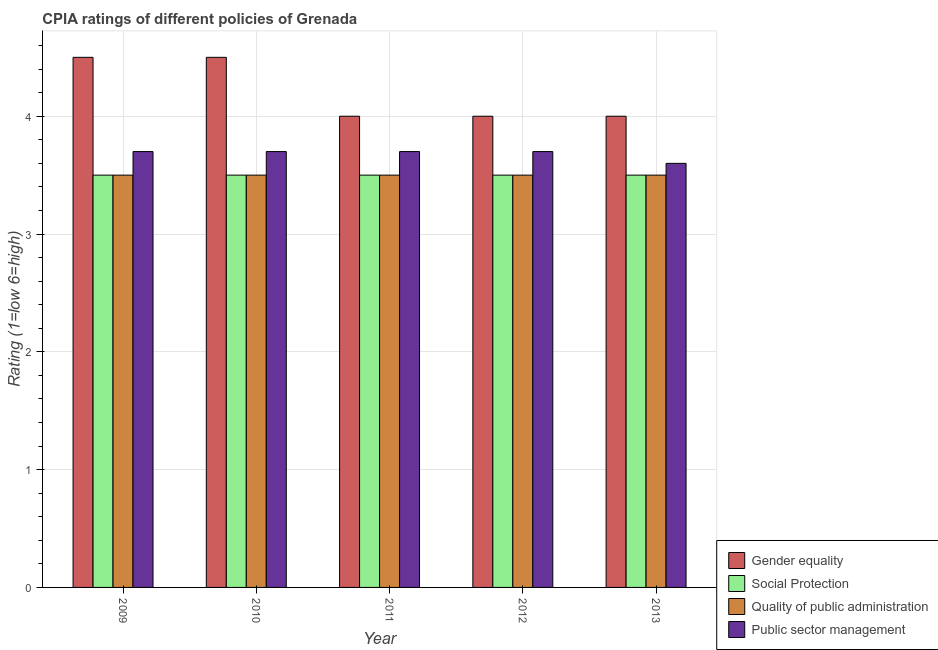How many different coloured bars are there?
Provide a succinct answer. 4. Are the number of bars per tick equal to the number of legend labels?
Your answer should be very brief. Yes. Are the number of bars on each tick of the X-axis equal?
Offer a terse response. Yes. How many bars are there on the 3rd tick from the right?
Your response must be concise. 4. In how many cases, is the number of bars for a given year not equal to the number of legend labels?
Keep it short and to the point. 0. What is the cpia rating of quality of public administration in 2009?
Offer a very short reply. 3.5. Across all years, what is the maximum cpia rating of quality of public administration?
Provide a succinct answer. 3.5. In which year was the cpia rating of quality of public administration maximum?
Make the answer very short. 2009. In which year was the cpia rating of gender equality minimum?
Ensure brevity in your answer.  2011. What is the total cpia rating of public sector management in the graph?
Offer a terse response. 18.4. What is the difference between the cpia rating of social protection in 2009 and that in 2011?
Provide a succinct answer. 0. What is the difference between the cpia rating of gender equality in 2013 and the cpia rating of public sector management in 2009?
Provide a succinct answer. -0.5. In the year 2013, what is the difference between the cpia rating of social protection and cpia rating of public sector management?
Provide a succinct answer. 0. What is the ratio of the cpia rating of public sector management in 2011 to that in 2013?
Make the answer very short. 1.03. Is the cpia rating of social protection in 2011 less than that in 2013?
Your answer should be compact. No. In how many years, is the cpia rating of gender equality greater than the average cpia rating of gender equality taken over all years?
Keep it short and to the point. 2. Is the sum of the cpia rating of social protection in 2012 and 2013 greater than the maximum cpia rating of gender equality across all years?
Give a very brief answer. Yes. What does the 3rd bar from the left in 2009 represents?
Ensure brevity in your answer.  Quality of public administration. What does the 1st bar from the right in 2011 represents?
Your answer should be compact. Public sector management. How many bars are there?
Offer a very short reply. 20. Are all the bars in the graph horizontal?
Your answer should be compact. No. What is the difference between two consecutive major ticks on the Y-axis?
Give a very brief answer. 1. Are the values on the major ticks of Y-axis written in scientific E-notation?
Your answer should be very brief. No. Does the graph contain any zero values?
Your answer should be very brief. No. Does the graph contain grids?
Your answer should be very brief. Yes. How many legend labels are there?
Provide a short and direct response. 4. What is the title of the graph?
Keep it short and to the point. CPIA ratings of different policies of Grenada. What is the Rating (1=low 6=high) of Gender equality in 2009?
Your answer should be very brief. 4.5. What is the Rating (1=low 6=high) in Social Protection in 2009?
Offer a terse response. 3.5. What is the Rating (1=low 6=high) in Gender equality in 2010?
Your answer should be compact. 4.5. What is the Rating (1=low 6=high) of Gender equality in 2011?
Keep it short and to the point. 4. What is the Rating (1=low 6=high) in Quality of public administration in 2011?
Your answer should be compact. 3.5. What is the Rating (1=low 6=high) in Quality of public administration in 2012?
Give a very brief answer. 3.5. What is the Rating (1=low 6=high) in Gender equality in 2013?
Offer a very short reply. 4. What is the Rating (1=low 6=high) in Social Protection in 2013?
Keep it short and to the point. 3.5. What is the Rating (1=low 6=high) of Public sector management in 2013?
Provide a short and direct response. 3.6. Across all years, what is the maximum Rating (1=low 6=high) in Public sector management?
Provide a short and direct response. 3.7. Across all years, what is the minimum Rating (1=low 6=high) in Gender equality?
Keep it short and to the point. 4. What is the total Rating (1=low 6=high) of Quality of public administration in the graph?
Your answer should be compact. 17.5. What is the difference between the Rating (1=low 6=high) of Gender equality in 2009 and that in 2010?
Provide a short and direct response. 0. What is the difference between the Rating (1=low 6=high) of Social Protection in 2009 and that in 2011?
Keep it short and to the point. 0. What is the difference between the Rating (1=low 6=high) in Quality of public administration in 2009 and that in 2011?
Provide a short and direct response. 0. What is the difference between the Rating (1=low 6=high) in Public sector management in 2009 and that in 2011?
Your answer should be compact. 0. What is the difference between the Rating (1=low 6=high) in Gender equality in 2009 and that in 2012?
Offer a very short reply. 0.5. What is the difference between the Rating (1=low 6=high) of Social Protection in 2009 and that in 2012?
Offer a terse response. 0. What is the difference between the Rating (1=low 6=high) in Quality of public administration in 2009 and that in 2013?
Provide a short and direct response. 0. What is the difference between the Rating (1=low 6=high) in Public sector management in 2009 and that in 2013?
Provide a succinct answer. 0.1. What is the difference between the Rating (1=low 6=high) in Social Protection in 2010 and that in 2011?
Give a very brief answer. 0. What is the difference between the Rating (1=low 6=high) in Quality of public administration in 2010 and that in 2011?
Provide a short and direct response. 0. What is the difference between the Rating (1=low 6=high) in Gender equality in 2010 and that in 2012?
Your answer should be very brief. 0.5. What is the difference between the Rating (1=low 6=high) of Social Protection in 2010 and that in 2012?
Provide a short and direct response. 0. What is the difference between the Rating (1=low 6=high) of Quality of public administration in 2010 and that in 2012?
Your response must be concise. 0. What is the difference between the Rating (1=low 6=high) of Public sector management in 2010 and that in 2012?
Keep it short and to the point. 0. What is the difference between the Rating (1=low 6=high) in Social Protection in 2010 and that in 2013?
Your response must be concise. 0. What is the difference between the Rating (1=low 6=high) in Social Protection in 2011 and that in 2012?
Keep it short and to the point. 0. What is the difference between the Rating (1=low 6=high) in Quality of public administration in 2011 and that in 2012?
Offer a terse response. 0. What is the difference between the Rating (1=low 6=high) in Gender equality in 2011 and that in 2013?
Provide a succinct answer. 0. What is the difference between the Rating (1=low 6=high) of Quality of public administration in 2011 and that in 2013?
Your answer should be compact. 0. What is the difference between the Rating (1=low 6=high) of Public sector management in 2011 and that in 2013?
Give a very brief answer. 0.1. What is the difference between the Rating (1=low 6=high) in Gender equality in 2012 and that in 2013?
Make the answer very short. 0. What is the difference between the Rating (1=low 6=high) in Public sector management in 2012 and that in 2013?
Give a very brief answer. 0.1. What is the difference between the Rating (1=low 6=high) of Gender equality in 2009 and the Rating (1=low 6=high) of Social Protection in 2010?
Provide a succinct answer. 1. What is the difference between the Rating (1=low 6=high) in Gender equality in 2009 and the Rating (1=low 6=high) in Public sector management in 2010?
Your answer should be compact. 0.8. What is the difference between the Rating (1=low 6=high) of Quality of public administration in 2009 and the Rating (1=low 6=high) of Public sector management in 2010?
Keep it short and to the point. -0.2. What is the difference between the Rating (1=low 6=high) of Gender equality in 2009 and the Rating (1=low 6=high) of Public sector management in 2011?
Your answer should be compact. 0.8. What is the difference between the Rating (1=low 6=high) of Social Protection in 2009 and the Rating (1=low 6=high) of Quality of public administration in 2011?
Your response must be concise. 0. What is the difference between the Rating (1=low 6=high) of Social Protection in 2009 and the Rating (1=low 6=high) of Public sector management in 2011?
Provide a succinct answer. -0.2. What is the difference between the Rating (1=low 6=high) in Gender equality in 2009 and the Rating (1=low 6=high) in Quality of public administration in 2012?
Give a very brief answer. 1. What is the difference between the Rating (1=low 6=high) in Social Protection in 2009 and the Rating (1=low 6=high) in Public sector management in 2012?
Offer a very short reply. -0.2. What is the difference between the Rating (1=low 6=high) in Quality of public administration in 2009 and the Rating (1=low 6=high) in Public sector management in 2012?
Your answer should be compact. -0.2. What is the difference between the Rating (1=low 6=high) in Gender equality in 2009 and the Rating (1=low 6=high) in Quality of public administration in 2013?
Your answer should be compact. 1. What is the difference between the Rating (1=low 6=high) of Gender equality in 2009 and the Rating (1=low 6=high) of Public sector management in 2013?
Offer a terse response. 0.9. What is the difference between the Rating (1=low 6=high) in Social Protection in 2009 and the Rating (1=low 6=high) in Public sector management in 2013?
Offer a terse response. -0.1. What is the difference between the Rating (1=low 6=high) in Quality of public administration in 2009 and the Rating (1=low 6=high) in Public sector management in 2013?
Your answer should be very brief. -0.1. What is the difference between the Rating (1=low 6=high) in Gender equality in 2010 and the Rating (1=low 6=high) in Social Protection in 2011?
Your answer should be compact. 1. What is the difference between the Rating (1=low 6=high) in Gender equality in 2010 and the Rating (1=low 6=high) in Public sector management in 2011?
Offer a very short reply. 0.8. What is the difference between the Rating (1=low 6=high) of Social Protection in 2010 and the Rating (1=low 6=high) of Quality of public administration in 2011?
Keep it short and to the point. 0. What is the difference between the Rating (1=low 6=high) of Social Protection in 2010 and the Rating (1=low 6=high) of Public sector management in 2011?
Give a very brief answer. -0.2. What is the difference between the Rating (1=low 6=high) in Gender equality in 2010 and the Rating (1=low 6=high) in Social Protection in 2012?
Provide a succinct answer. 1. What is the difference between the Rating (1=low 6=high) in Gender equality in 2010 and the Rating (1=low 6=high) in Quality of public administration in 2012?
Your answer should be very brief. 1. What is the difference between the Rating (1=low 6=high) of Gender equality in 2010 and the Rating (1=low 6=high) of Public sector management in 2012?
Ensure brevity in your answer.  0.8. What is the difference between the Rating (1=low 6=high) in Gender equality in 2010 and the Rating (1=low 6=high) in Quality of public administration in 2013?
Ensure brevity in your answer.  1. What is the difference between the Rating (1=low 6=high) in Social Protection in 2010 and the Rating (1=low 6=high) in Quality of public administration in 2013?
Make the answer very short. 0. What is the difference between the Rating (1=low 6=high) of Gender equality in 2011 and the Rating (1=low 6=high) of Social Protection in 2012?
Your answer should be very brief. 0.5. What is the difference between the Rating (1=low 6=high) in Gender equality in 2011 and the Rating (1=low 6=high) in Quality of public administration in 2012?
Offer a terse response. 0.5. What is the difference between the Rating (1=low 6=high) in Gender equality in 2011 and the Rating (1=low 6=high) in Public sector management in 2012?
Offer a very short reply. 0.3. What is the difference between the Rating (1=low 6=high) of Social Protection in 2011 and the Rating (1=low 6=high) of Public sector management in 2012?
Ensure brevity in your answer.  -0.2. What is the difference between the Rating (1=low 6=high) of Quality of public administration in 2011 and the Rating (1=low 6=high) of Public sector management in 2012?
Your answer should be very brief. -0.2. What is the difference between the Rating (1=low 6=high) in Gender equality in 2011 and the Rating (1=low 6=high) in Public sector management in 2013?
Make the answer very short. 0.4. What is the difference between the Rating (1=low 6=high) in Social Protection in 2011 and the Rating (1=low 6=high) in Quality of public administration in 2013?
Make the answer very short. 0. What is the difference between the Rating (1=low 6=high) of Social Protection in 2011 and the Rating (1=low 6=high) of Public sector management in 2013?
Ensure brevity in your answer.  -0.1. What is the difference between the Rating (1=low 6=high) in Quality of public administration in 2011 and the Rating (1=low 6=high) in Public sector management in 2013?
Ensure brevity in your answer.  -0.1. What is the difference between the Rating (1=low 6=high) of Gender equality in 2012 and the Rating (1=low 6=high) of Quality of public administration in 2013?
Give a very brief answer. 0.5. What is the difference between the Rating (1=low 6=high) in Quality of public administration in 2012 and the Rating (1=low 6=high) in Public sector management in 2013?
Offer a terse response. -0.1. What is the average Rating (1=low 6=high) of Gender equality per year?
Provide a succinct answer. 4.2. What is the average Rating (1=low 6=high) in Quality of public administration per year?
Your answer should be compact. 3.5. What is the average Rating (1=low 6=high) of Public sector management per year?
Provide a succinct answer. 3.68. In the year 2009, what is the difference between the Rating (1=low 6=high) in Gender equality and Rating (1=low 6=high) in Quality of public administration?
Provide a short and direct response. 1. In the year 2009, what is the difference between the Rating (1=low 6=high) in Social Protection and Rating (1=low 6=high) in Public sector management?
Offer a very short reply. -0.2. In the year 2009, what is the difference between the Rating (1=low 6=high) in Quality of public administration and Rating (1=low 6=high) in Public sector management?
Make the answer very short. -0.2. In the year 2010, what is the difference between the Rating (1=low 6=high) of Gender equality and Rating (1=low 6=high) of Social Protection?
Give a very brief answer. 1. In the year 2010, what is the difference between the Rating (1=low 6=high) of Gender equality and Rating (1=low 6=high) of Quality of public administration?
Your answer should be compact. 1. In the year 2010, what is the difference between the Rating (1=low 6=high) of Gender equality and Rating (1=low 6=high) of Public sector management?
Make the answer very short. 0.8. In the year 2010, what is the difference between the Rating (1=low 6=high) of Social Protection and Rating (1=low 6=high) of Quality of public administration?
Provide a succinct answer. 0. In the year 2010, what is the difference between the Rating (1=low 6=high) of Social Protection and Rating (1=low 6=high) of Public sector management?
Offer a terse response. -0.2. In the year 2010, what is the difference between the Rating (1=low 6=high) in Quality of public administration and Rating (1=low 6=high) in Public sector management?
Your answer should be compact. -0.2. In the year 2011, what is the difference between the Rating (1=low 6=high) of Gender equality and Rating (1=low 6=high) of Social Protection?
Your answer should be compact. 0.5. In the year 2011, what is the difference between the Rating (1=low 6=high) of Gender equality and Rating (1=low 6=high) of Public sector management?
Make the answer very short. 0.3. In the year 2011, what is the difference between the Rating (1=low 6=high) of Social Protection and Rating (1=low 6=high) of Quality of public administration?
Offer a very short reply. 0. In the year 2012, what is the difference between the Rating (1=low 6=high) of Gender equality and Rating (1=low 6=high) of Quality of public administration?
Provide a short and direct response. 0.5. In the year 2012, what is the difference between the Rating (1=low 6=high) in Social Protection and Rating (1=low 6=high) in Public sector management?
Your response must be concise. -0.2. In the year 2013, what is the difference between the Rating (1=low 6=high) in Gender equality and Rating (1=low 6=high) in Quality of public administration?
Give a very brief answer. 0.5. In the year 2013, what is the difference between the Rating (1=low 6=high) of Quality of public administration and Rating (1=low 6=high) of Public sector management?
Provide a short and direct response. -0.1. What is the ratio of the Rating (1=low 6=high) in Gender equality in 2009 to that in 2010?
Keep it short and to the point. 1. What is the ratio of the Rating (1=low 6=high) of Quality of public administration in 2009 to that in 2010?
Offer a terse response. 1. What is the ratio of the Rating (1=low 6=high) in Social Protection in 2009 to that in 2011?
Offer a terse response. 1. What is the ratio of the Rating (1=low 6=high) of Quality of public administration in 2009 to that in 2011?
Your answer should be compact. 1. What is the ratio of the Rating (1=low 6=high) in Public sector management in 2009 to that in 2011?
Offer a very short reply. 1. What is the ratio of the Rating (1=low 6=high) in Gender equality in 2009 to that in 2012?
Keep it short and to the point. 1.12. What is the ratio of the Rating (1=low 6=high) in Gender equality in 2009 to that in 2013?
Ensure brevity in your answer.  1.12. What is the ratio of the Rating (1=low 6=high) in Social Protection in 2009 to that in 2013?
Give a very brief answer. 1. What is the ratio of the Rating (1=low 6=high) of Public sector management in 2009 to that in 2013?
Offer a terse response. 1.03. What is the ratio of the Rating (1=low 6=high) in Gender equality in 2010 to that in 2011?
Offer a very short reply. 1.12. What is the ratio of the Rating (1=low 6=high) of Quality of public administration in 2010 to that in 2011?
Your answer should be very brief. 1. What is the ratio of the Rating (1=low 6=high) in Gender equality in 2010 to that in 2012?
Make the answer very short. 1.12. What is the ratio of the Rating (1=low 6=high) of Gender equality in 2010 to that in 2013?
Give a very brief answer. 1.12. What is the ratio of the Rating (1=low 6=high) in Public sector management in 2010 to that in 2013?
Make the answer very short. 1.03. What is the ratio of the Rating (1=low 6=high) of Quality of public administration in 2011 to that in 2013?
Ensure brevity in your answer.  1. What is the ratio of the Rating (1=low 6=high) in Public sector management in 2011 to that in 2013?
Offer a terse response. 1.03. What is the ratio of the Rating (1=low 6=high) in Gender equality in 2012 to that in 2013?
Your response must be concise. 1. What is the ratio of the Rating (1=low 6=high) in Quality of public administration in 2012 to that in 2013?
Provide a succinct answer. 1. What is the ratio of the Rating (1=low 6=high) of Public sector management in 2012 to that in 2013?
Ensure brevity in your answer.  1.03. What is the difference between the highest and the second highest Rating (1=low 6=high) in Social Protection?
Offer a very short reply. 0. What is the difference between the highest and the lowest Rating (1=low 6=high) in Gender equality?
Ensure brevity in your answer.  0.5. What is the difference between the highest and the lowest Rating (1=low 6=high) of Social Protection?
Keep it short and to the point. 0. 